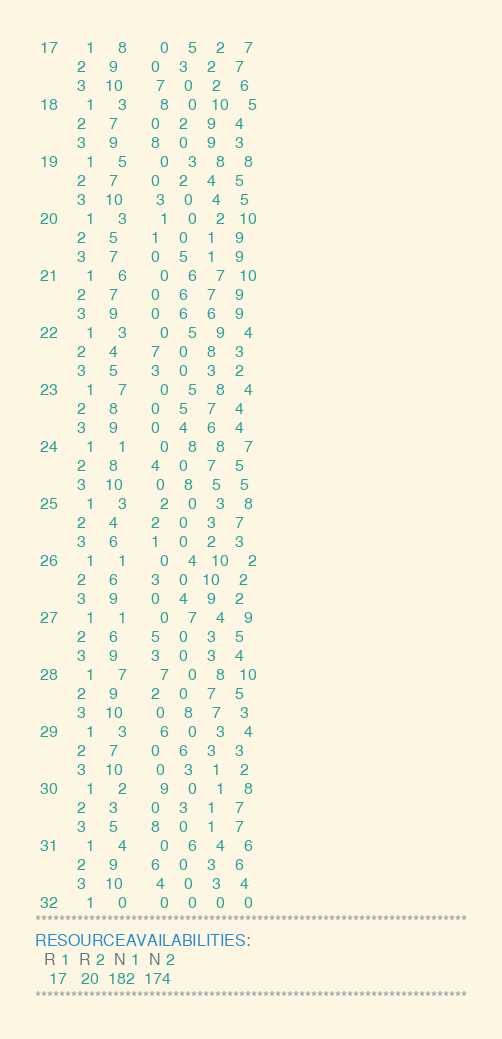Convert code to text. <code><loc_0><loc_0><loc_500><loc_500><_ObjectiveC_> 17      1     8       0    5    2    7
         2     9       0    3    2    7
         3    10       7    0    2    6
 18      1     3       8    0   10    5
         2     7       0    2    9    4
         3     9       8    0    9    3
 19      1     5       0    3    8    8
         2     7       0    2    4    5
         3    10       3    0    4    5
 20      1     3       1    0    2   10
         2     5       1    0    1    9
         3     7       0    5    1    9
 21      1     6       0    6    7   10
         2     7       0    6    7    9
         3     9       0    6    6    9
 22      1     3       0    5    9    4
         2     4       7    0    8    3
         3     5       3    0    3    2
 23      1     7       0    5    8    4
         2     8       0    5    7    4
         3     9       0    4    6    4
 24      1     1       0    8    8    7
         2     8       4    0    7    5
         3    10       0    8    5    5
 25      1     3       2    0    3    8
         2     4       2    0    3    7
         3     6       1    0    2    3
 26      1     1       0    4   10    2
         2     6       3    0   10    2
         3     9       0    4    9    2
 27      1     1       0    7    4    9
         2     6       5    0    3    5
         3     9       3    0    3    4
 28      1     7       7    0    8   10
         2     9       2    0    7    5
         3    10       0    8    7    3
 29      1     3       6    0    3    4
         2     7       0    6    3    3
         3    10       0    3    1    2
 30      1     2       9    0    1    8
         2     3       0    3    1    7
         3     5       8    0    1    7
 31      1     4       0    6    4    6
         2     9       6    0    3    6
         3    10       4    0    3    4
 32      1     0       0    0    0    0
************************************************************************
RESOURCEAVAILABILITIES:
  R 1  R 2  N 1  N 2
   17   20  182  174
************************************************************************
</code> 